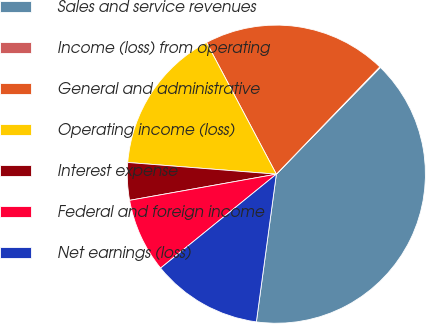<chart> <loc_0><loc_0><loc_500><loc_500><pie_chart><fcel>Sales and service revenues<fcel>Income (loss) from operating<fcel>General and administrative<fcel>Operating income (loss)<fcel>Interest expense<fcel>Federal and foreign income<fcel>Net earnings (loss)<nl><fcel>39.85%<fcel>0.08%<fcel>19.97%<fcel>15.99%<fcel>4.06%<fcel>8.04%<fcel>12.01%<nl></chart> 